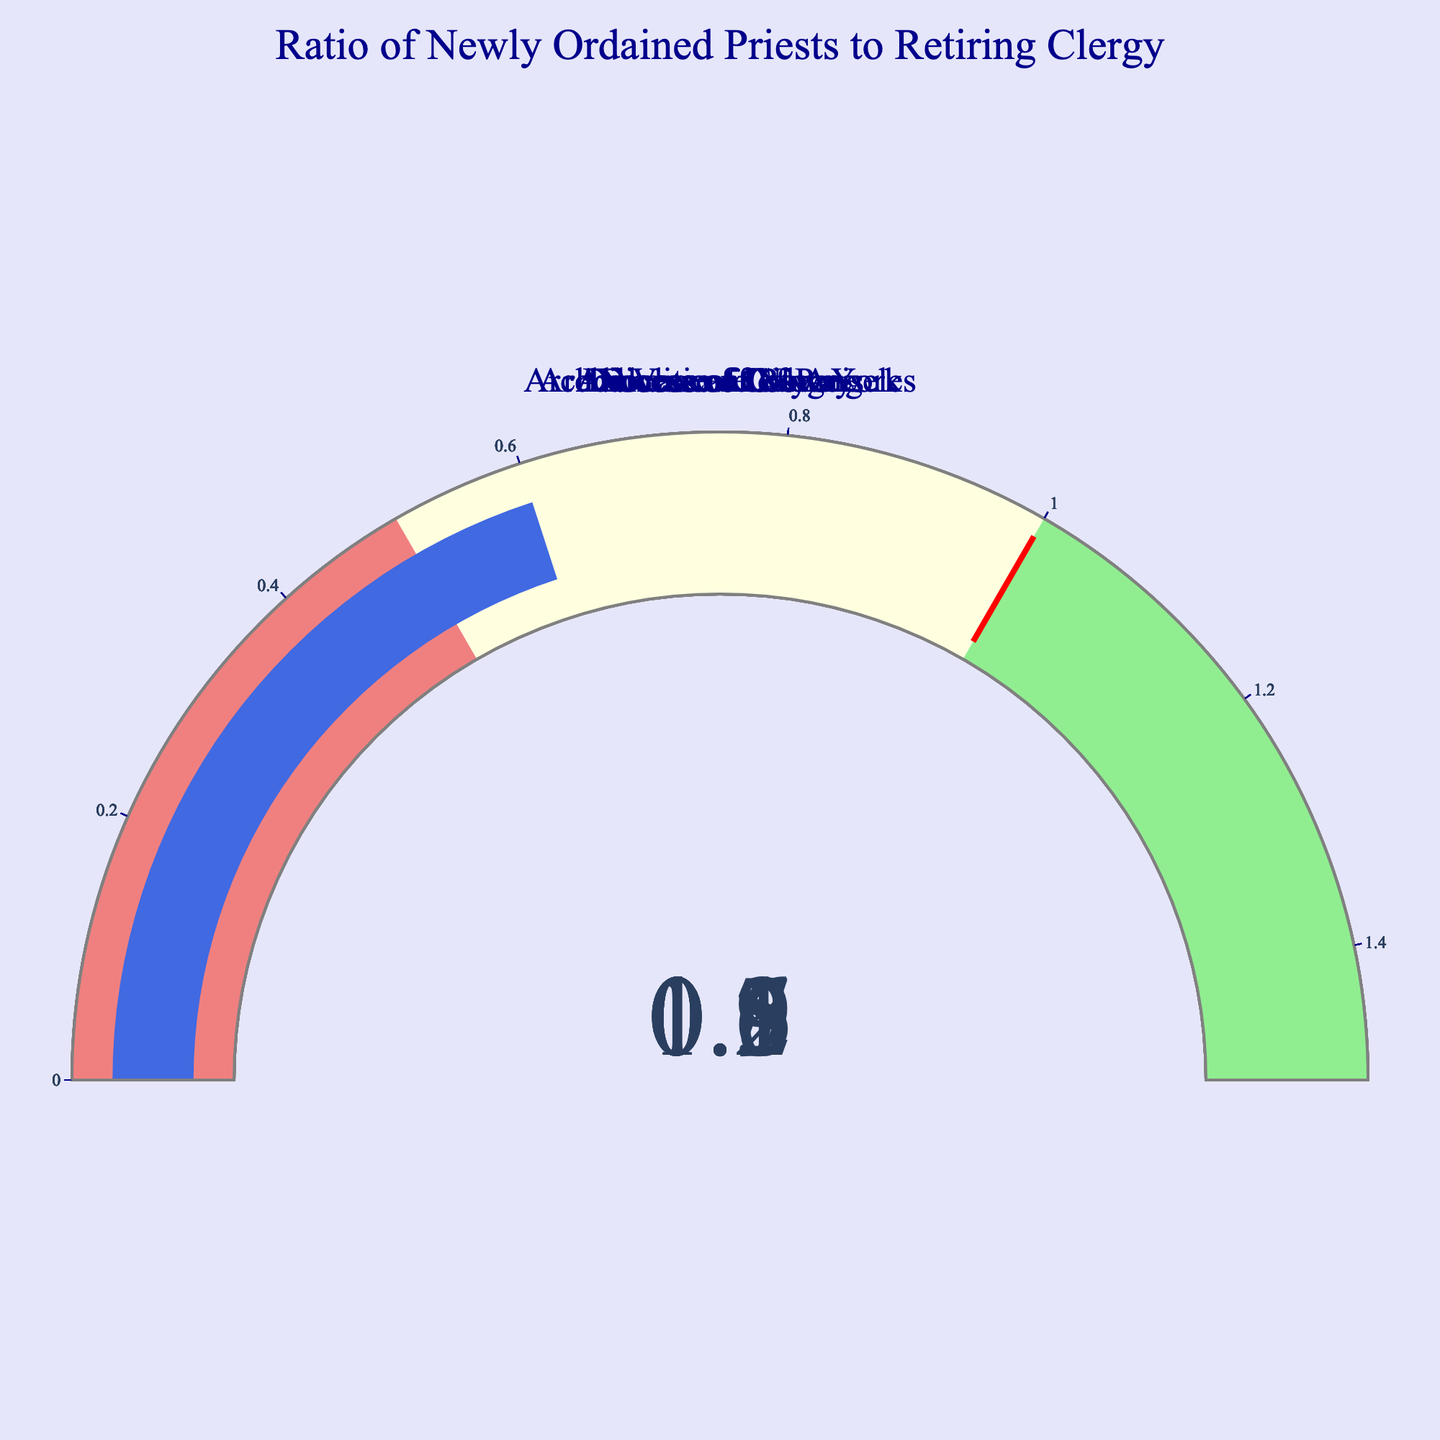Which diocese has the highest ratio of newly ordained priests to retiring clergy? To determine this, we examine each gauge's value. Vatican City has the highest reading at 1.2.
Answer: Vatican City Which diocese has the lowest ratio of newly ordained priests to retiring clergy? By looking at the gauge values, the Diocese of Galway has the lowest ratio of 0.5.
Answer: Diocese of Galway Which dioceses have a ratio greater than 1? Gauges that display a value over 1 qualify. Here, Vatican City (1.2) and Diocese of Rome (1.1) meet this criterion.
Answer: Vatican City, Diocese of Rome Is any diocese’s ratio falling exactly at the threshold value (1)? Checking all the gauges, none of the dioceses has an exact value of 1.
Answer: No How many dioceses have ratios in the "lightgreen" section (greater than 1)? The "lightgreen" section corresponds to values over 1. Both Vatican City and Diocese of Rome fall into this category.
Answer: 2 Which dioceses have ratios between 0.5 and 1? Values in the range of 0.5 to 1 are highlighted in "lightyellow." These dioceses are Archdiocese of New York (0.8), Archdiocese of Los Angeles (0.9), and Diocese of Cologne (0.6).
Answer: Archdiocese of New York, Archdiocese of Los Angeles, Diocese of Cologne What is the average ratio of newly ordained priests to retiring clergy across all dioceses? Sum the values (1.2 + 0.8 + 1.1 + 0.7 + 0.5 + 0.9 + 0.6) to get 5.8, then divide by the number of data points (7) for the average: 5.8/7 ≈ 0.83.
Answer: 0.83 What is the difference between the highest and the lowest ratio? Subtract the lowest ratio (0.5, from Diocese of Galway) from the highest ratio (1.2, from Vatican City): 1.2 - 0.5 = 0.7.
Answer: 0.7 Which diocese has a ratio that is equal to or greater than the threshold of 1? Dioceses with ratios of 1 or higher are Vatican City (1.2) and Diocese of Rome (1.1).
Answer: Vatican City, Diocese of Rome How many dioceses have ratios below the median ratio? First, rank the ratios: 0.5, 0.6, 0.7, 0.8, 0.9, 1.1, 1.2. The median (middle value) is 0.8; thus, the dioceses with ratios below this are Diocese of Galway (0.5) and Diocese of Cologne (0.6).
Answer: 2 